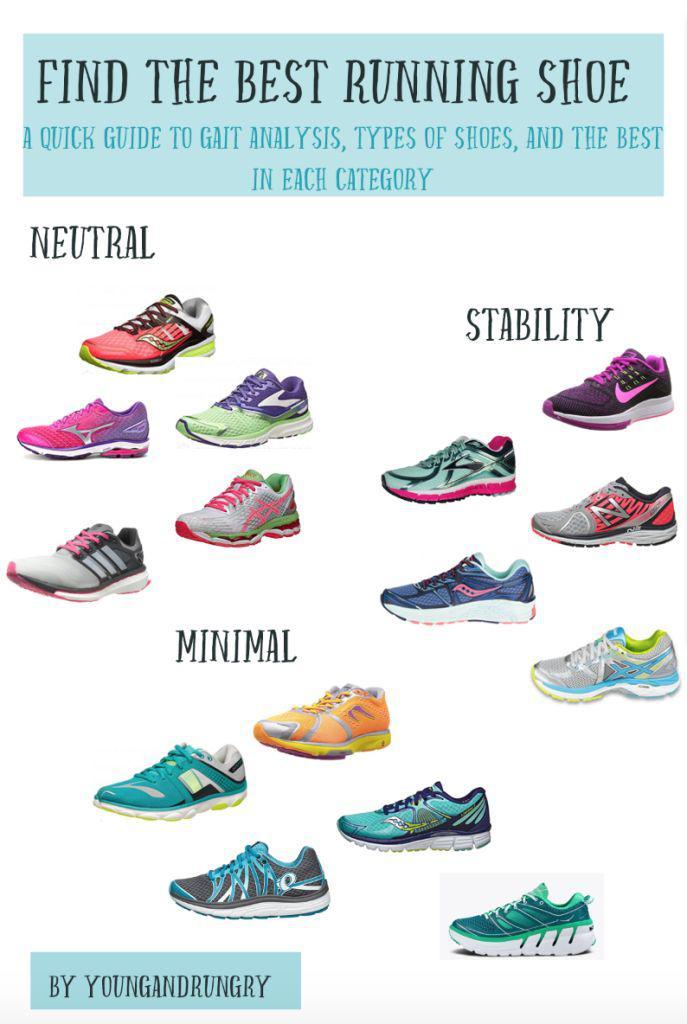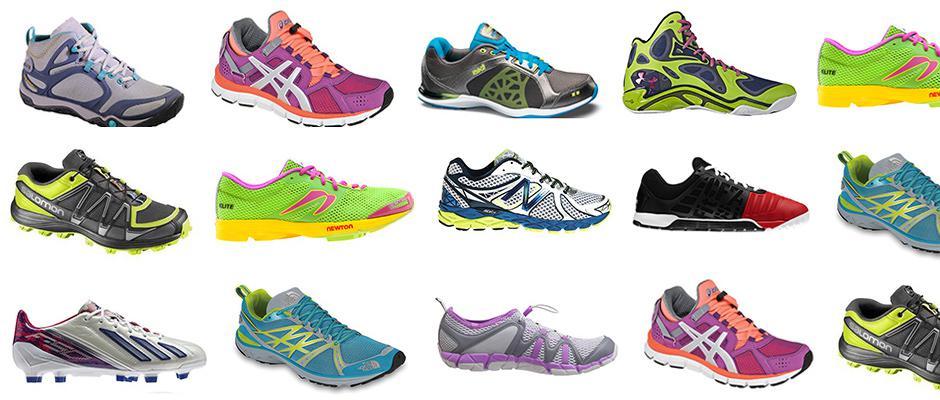The first image is the image on the left, the second image is the image on the right. For the images shown, is this caption "One image has less than sixteen shoes present." true? Answer yes or no. Yes. 